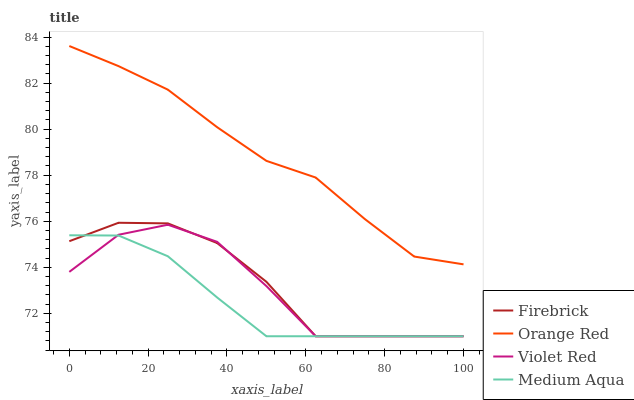Does Medium Aqua have the minimum area under the curve?
Answer yes or no. Yes. Does Orange Red have the maximum area under the curve?
Answer yes or no. Yes. Does Firebrick have the minimum area under the curve?
Answer yes or no. No. Does Firebrick have the maximum area under the curve?
Answer yes or no. No. Is Medium Aqua the smoothest?
Answer yes or no. Yes. Is Violet Red the roughest?
Answer yes or no. Yes. Is Firebrick the smoothest?
Answer yes or no. No. Is Firebrick the roughest?
Answer yes or no. No. Does Violet Red have the lowest value?
Answer yes or no. Yes. Does Orange Red have the lowest value?
Answer yes or no. No. Does Orange Red have the highest value?
Answer yes or no. Yes. Does Firebrick have the highest value?
Answer yes or no. No. Is Firebrick less than Orange Red?
Answer yes or no. Yes. Is Orange Red greater than Violet Red?
Answer yes or no. Yes. Does Medium Aqua intersect Firebrick?
Answer yes or no. Yes. Is Medium Aqua less than Firebrick?
Answer yes or no. No. Is Medium Aqua greater than Firebrick?
Answer yes or no. No. Does Firebrick intersect Orange Red?
Answer yes or no. No. 